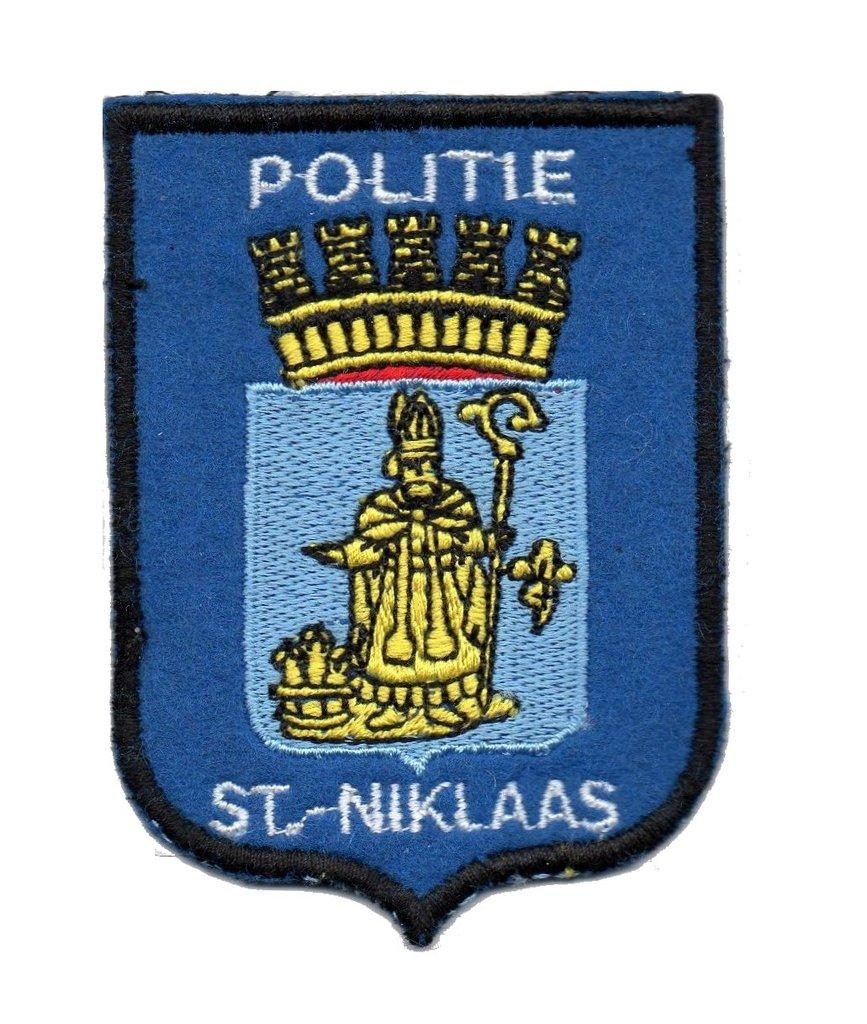What color is the batch in the image? The batch in the image is blue. What other elements are present on the batch? The batch has some text and a picture on it. What is the color of the background in the image? The background in the image is white. Can you tell me how many pears are depicted on the batch in the image? There are no pears depicted on the batch in the image; it only has text and a picture. 